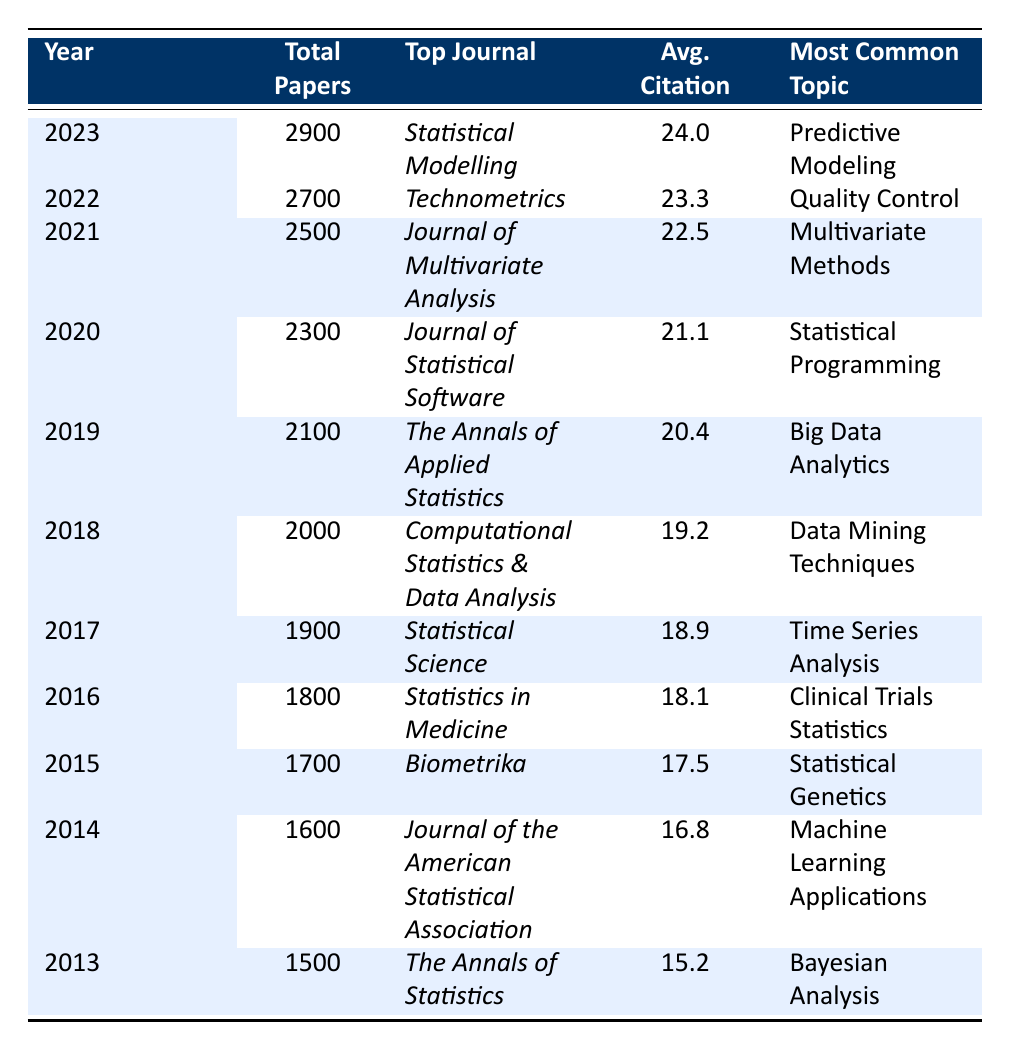What was the total number of papers published in 2021? The table indicates that the total number of papers published in 2021 is listed in the corresponding row, which shows 2500.
Answer: 2500 Which journal was the top publication in 2019? According to the table, the top journal in 2019 is mentioned in the appropriate row, which states "The Annals of Applied Statistics."
Answer: The Annals of Applied Statistics What is the average citation rate for papers published in 2020? The row for 2020 indicates that the average citation rate is 21.1, as shown in the corresponding column.
Answer: 21.1 In which year did the total number of papers published exceed 2000 for the first time? By examining the total papers column, the first year that exceeds 2000 is 2018, as it shows 2000 papers; 2017 has 1900, hence 2018 is the year of first exceeding 2000.
Answer: 2018 What was the most common topic in the year 2016? Referring to the entry for 2016, the most common topic is listed as "Clinical Trials Statistics."
Answer: Clinical Trials Statistics Was there a year that had more than 2300 papers published? The table shows that the total papers published in 2020, 2021, 2022, and 2023 exceed 2300.
Answer: Yes Calculate the average of the average citations from 2013 to 2016. The average citations for the years 2013 (15.2), 2014 (16.8), 2015 (17.5), and 2016 (18.1) sum to 67.6 (15.2 + 16.8 + 17.5 + 18.1). Dividing by 4, we get 67.6 / 4 = 16.9.
Answer: 16.9 What was the trend in the number of publications from 2013 to 2023? By analyzing the total papers published from each year sequentially, it shows a consistent increase: 1500 (2013), 1600 (2014), ... up to 2900 (2023). This indicates an upward trend.
Answer: Upward trend Identify the year with the highest average citation rate and state the value. The highest average citation rate is found in the last row for the year 2023, which shows an average citation of 24.0, the highest among all listed years.
Answer: 24.0 Was Bayesian Analysis the most common topic in the year with the lowest total publications? Checking the year with the lowest total papers (2013) confirms that the most common topic for that year is indeed "Bayesian Analysis."
Answer: Yes What is the difference in total papers published between 2022 and 2019? To solve, we subtract total papers in 2019 (2100) from total papers in 2022 (2700), resulting in 2700 - 2100 = 600.
Answer: 600 